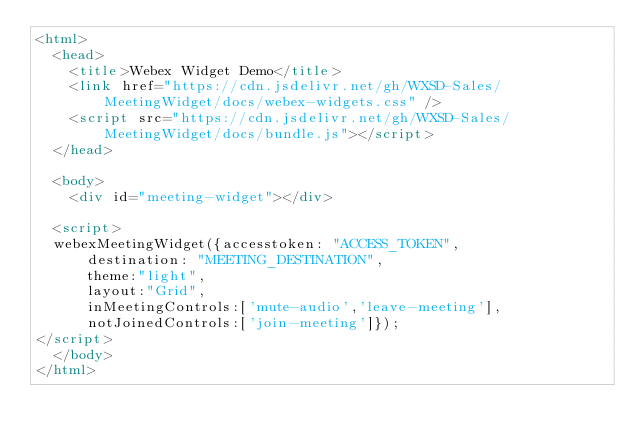Convert code to text. <code><loc_0><loc_0><loc_500><loc_500><_HTML_><html>
  <head>
    <title>Webex Widget Demo</title>
    <link href="https://cdn.jsdelivr.net/gh/WXSD-Sales/MeetingWidget/docs/webex-widgets.css" />
    <script src="https://cdn.jsdelivr.net/gh/WXSD-Sales/MeetingWidget/docs/bundle.js"></script>
  </head>

  <body>
    <div id="meeting-widget"></div>

  <script>
  webexMeetingWidget({accesstoken: "ACCESS_TOKEN",
      destination: "MEETING_DESTINATION",
      theme:"light",
      layout:"Grid",
      inMeetingControls:['mute-audio','leave-meeting'],
      notJoinedControls:['join-meeting']});
</script>
  </body>
</html>
</code> 